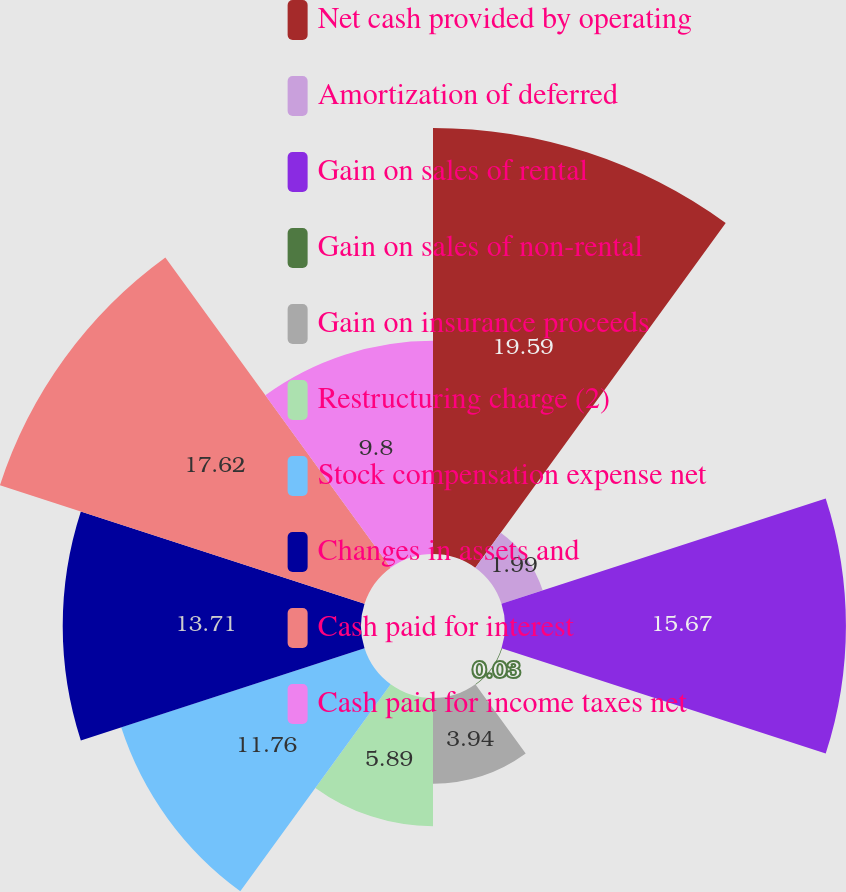Convert chart. <chart><loc_0><loc_0><loc_500><loc_500><pie_chart><fcel>Net cash provided by operating<fcel>Amortization of deferred<fcel>Gain on sales of rental<fcel>Gain on sales of non-rental<fcel>Gain on insurance proceeds<fcel>Restructuring charge (2)<fcel>Stock compensation expense net<fcel>Changes in assets and<fcel>Cash paid for interest<fcel>Cash paid for income taxes net<nl><fcel>19.58%<fcel>1.99%<fcel>15.67%<fcel>0.03%<fcel>3.94%<fcel>5.89%<fcel>11.76%<fcel>13.71%<fcel>17.62%<fcel>9.8%<nl></chart> 